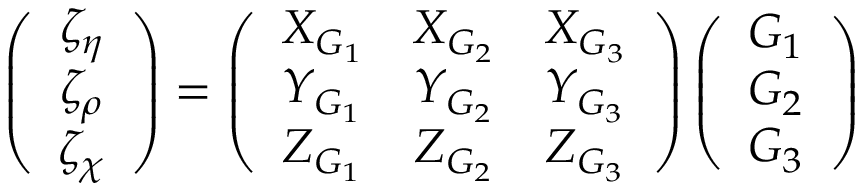Convert formula to latex. <formula><loc_0><loc_0><loc_500><loc_500>\left ( \begin{array} { c } { { \zeta _ { \eta } } } \\ { { \zeta _ { \rho } } } \\ { { \zeta _ { \chi } } } \end{array} \right ) = \left ( \begin{array} { c c c } { { X _ { G _ { 1 } } } } & { { X _ { G _ { 2 } } } } & { { X _ { G _ { 3 } } } } \\ { { Y _ { G _ { 1 } } } } & { { Y _ { G _ { 2 } } } } & { { Y _ { G _ { 3 } } } } \\ { { Z _ { G _ { 1 } } } } & { { Z _ { G _ { 2 } } } } & { { Z _ { G _ { 3 } } } } \end{array} \right ) \left ( \begin{array} { c } { { G _ { 1 } } } \\ { { G _ { 2 } } } \\ { { G _ { 3 } } } \end{array} \right )</formula> 